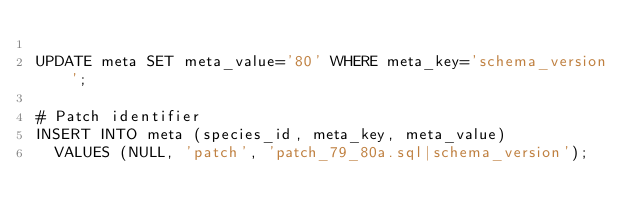<code> <loc_0><loc_0><loc_500><loc_500><_SQL_>
UPDATE meta SET meta_value='80' WHERE meta_key='schema_version';

# Patch identifier
INSERT INTO meta (species_id, meta_key, meta_value)
  VALUES (NULL, 'patch', 'patch_79_80a.sql|schema_version');
</code> 